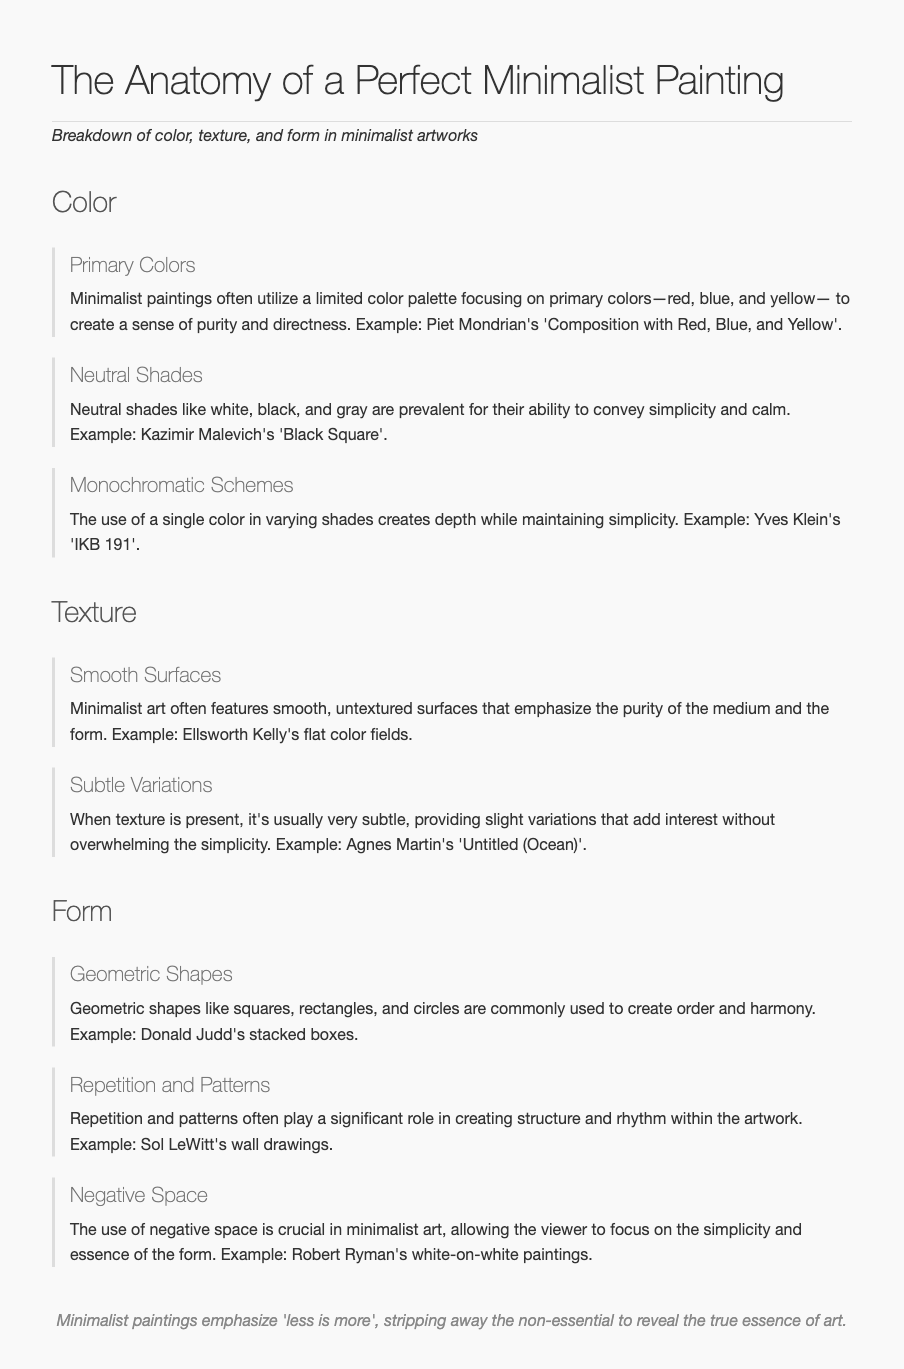What are the primary colors used in minimalist paintings? The document states that minimalist paintings utilize a limited color palette focusing on primary colors—red, blue, and yellow.
Answer: red, blue, and yellow Which minimalist painting is an example of neutral shades? Kazimir Malevich's 'Black Square' is specifically mentioned in the context of neutral shades.
Answer: Black Square What kind of surfaces does minimalist art often feature? The document mentions that minimalist art often features smooth, untextured surfaces.
Answer: smooth, untextured What role do geometric shapes play in minimalist art? According to the document, geometric shapes are commonly used to create order and harmony.
Answer: order and harmony Which artist is associated with stacked boxes in minimalist art? Donald Judd is the artist mentioned in relation to stacked boxes.
Answer: Donald Judd What is crucial in minimalist art, allowing focus on simplicity? The document highlights that the use of negative space is crucial in minimalist art.
Answer: negative space How does a monochromatic scheme affect depth? The document states that the use of a single color in varying shades creates depth while maintaining simplicity.
Answer: creates depth What phrase summarizes the essence of minimalist paintings? The footer of the document emphasizes that minimalist paintings emphasize 'less is more'.
Answer: less is more What does the document suggest about texture in minimalist art? It notes that when texture is present, it's usually very subtle, which adds interest without overwhelming simplicity.
Answer: very subtle 